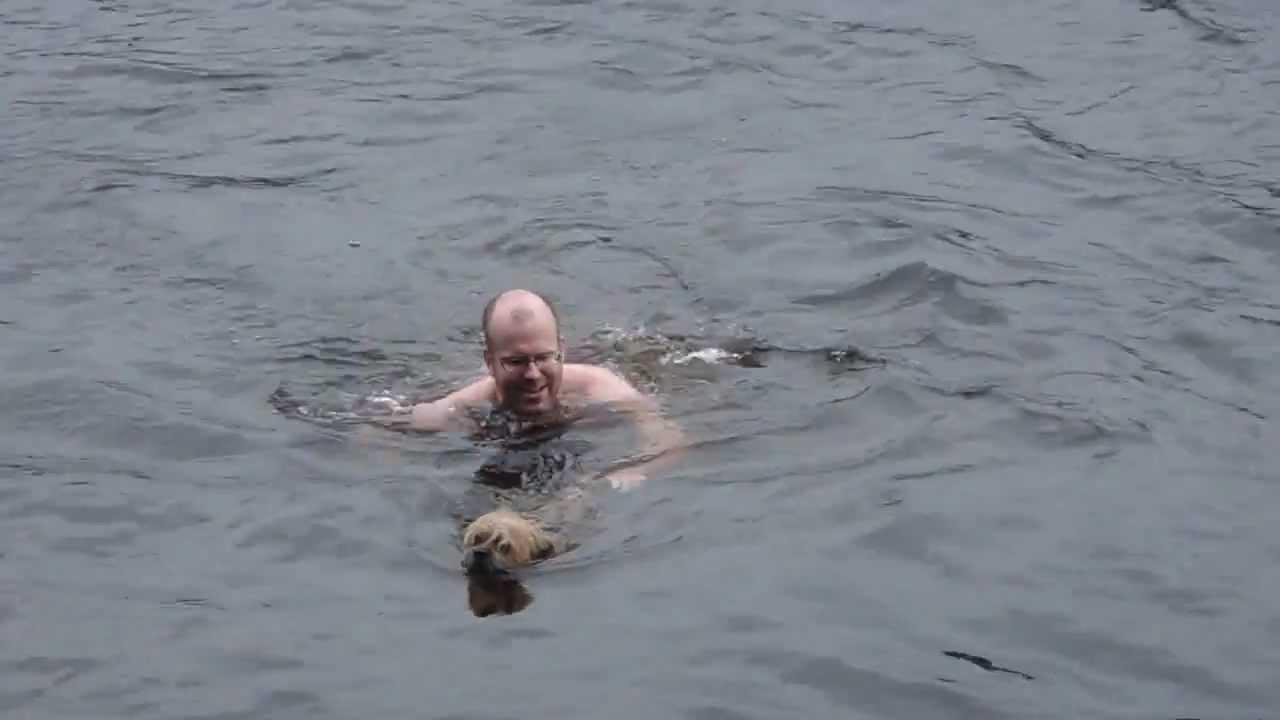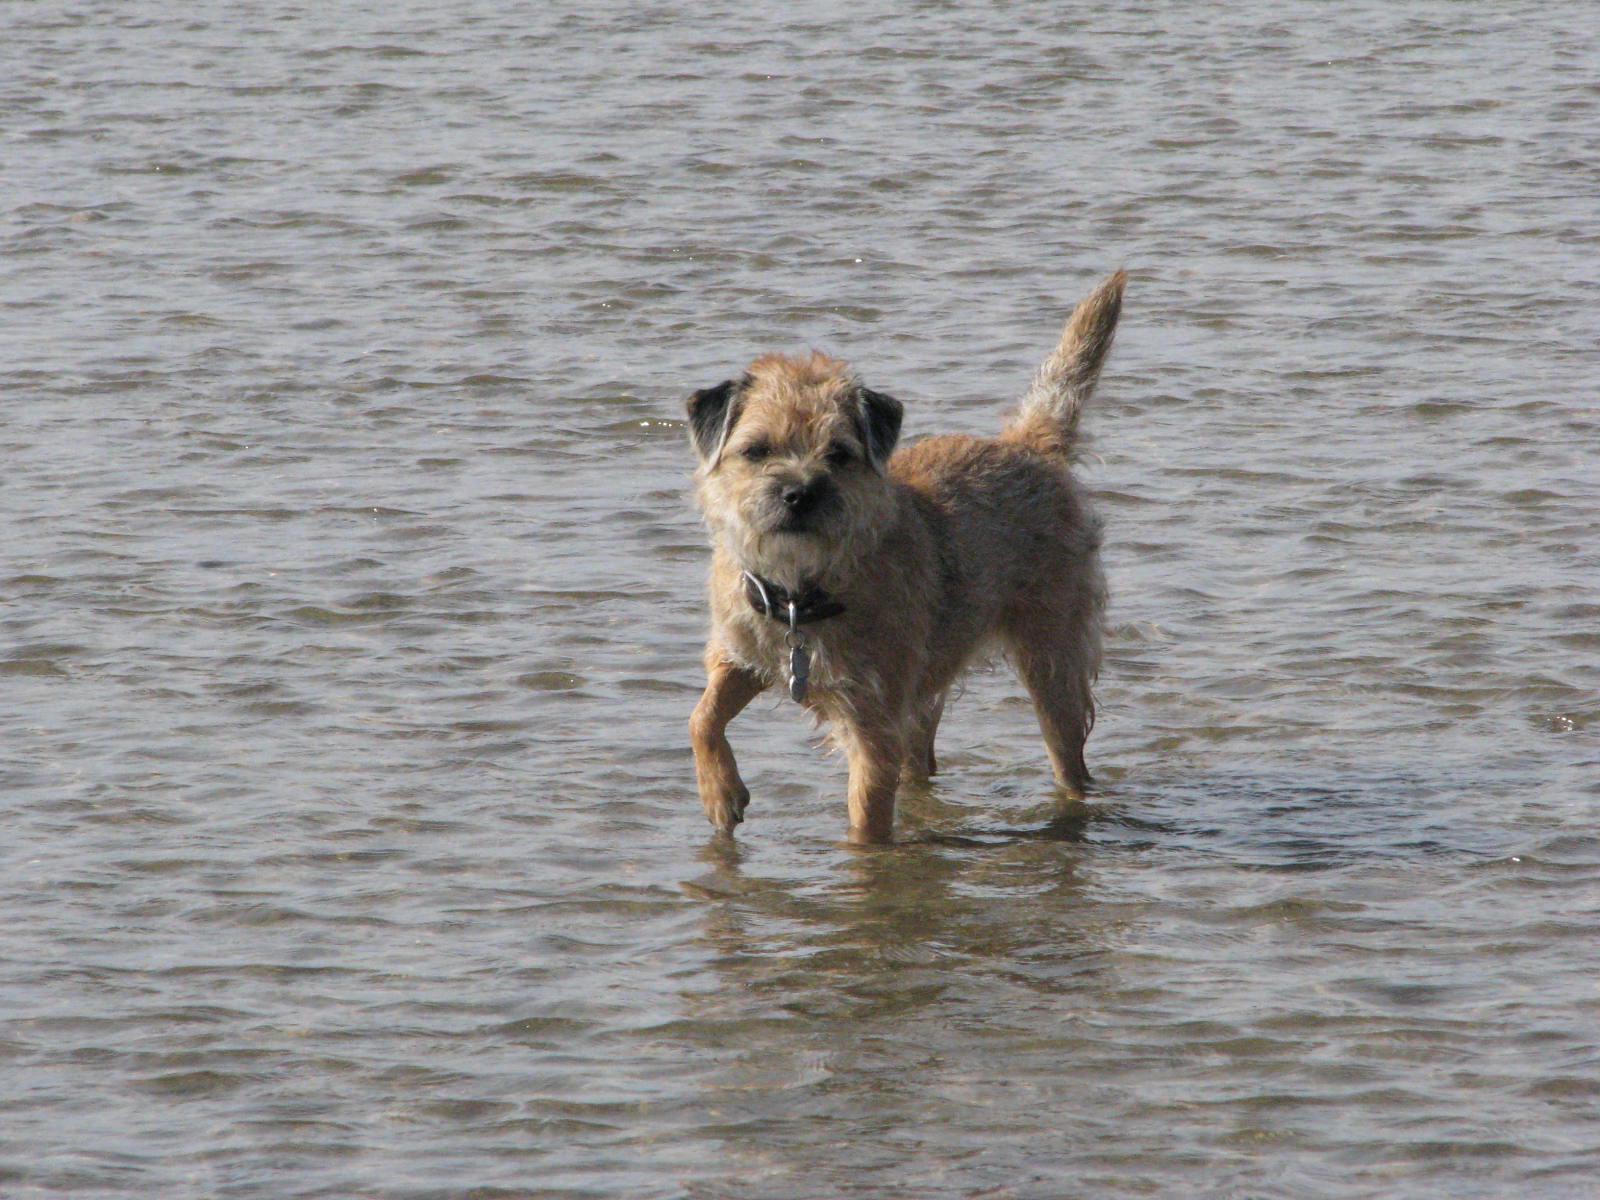The first image is the image on the left, the second image is the image on the right. Assess this claim about the two images: "There is a human in the water with at least one dog in the picture on the left.". Correct or not? Answer yes or no. Yes. The first image is the image on the left, the second image is the image on the right. Considering the images on both sides, is "A dog is in the water with a man." valid? Answer yes or no. Yes. 